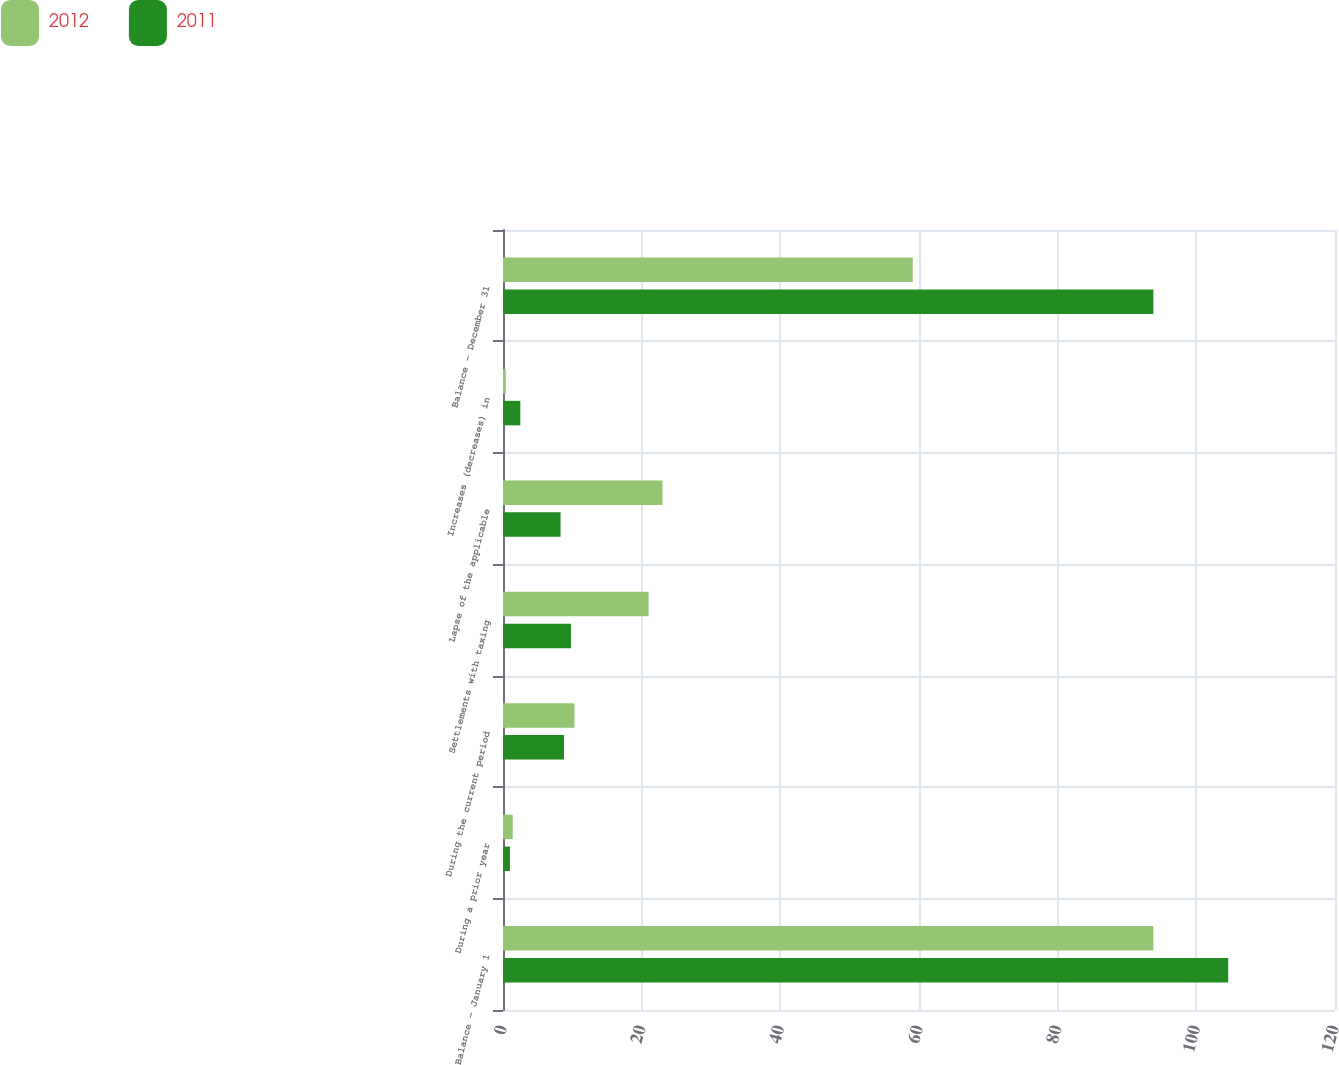Convert chart to OTSL. <chart><loc_0><loc_0><loc_500><loc_500><stacked_bar_chart><ecel><fcel>Balance - January 1<fcel>During a prior year<fcel>During the current period<fcel>Settlements with taxing<fcel>Lapse of the applicable<fcel>Increases (decreases) in<fcel>Balance - December 31<nl><fcel>2012<fcel>93.8<fcel>1.4<fcel>10.3<fcel>21<fcel>23<fcel>0.4<fcel>59.1<nl><fcel>2011<fcel>104.6<fcel>1<fcel>8.8<fcel>9.8<fcel>8.3<fcel>2.5<fcel>93.8<nl></chart> 